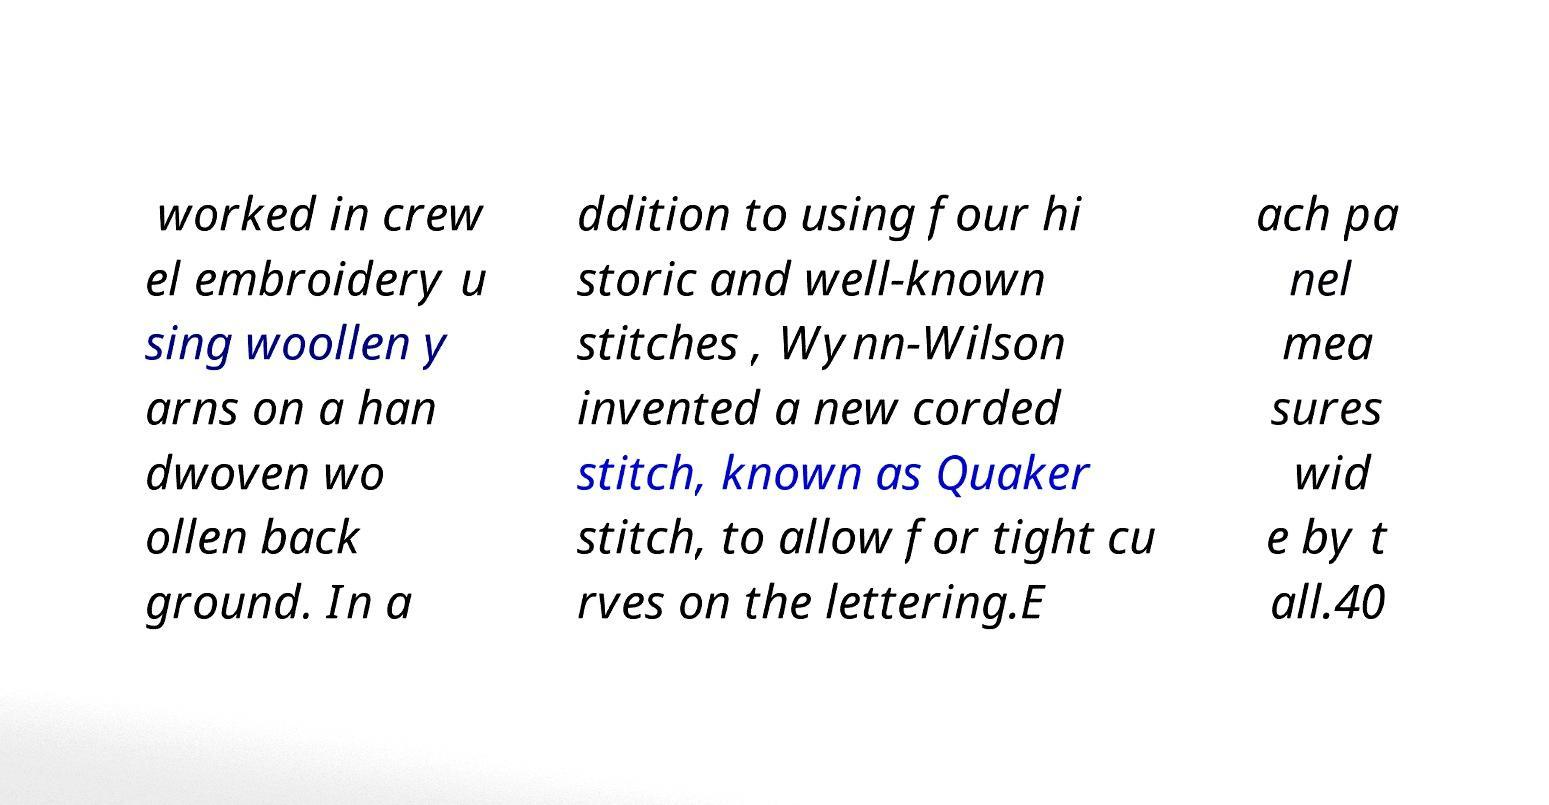I need the written content from this picture converted into text. Can you do that? worked in crew el embroidery u sing woollen y arns on a han dwoven wo ollen back ground. In a ddition to using four hi storic and well-known stitches , Wynn-Wilson invented a new corded stitch, known as Quaker stitch, to allow for tight cu rves on the lettering.E ach pa nel mea sures wid e by t all.40 